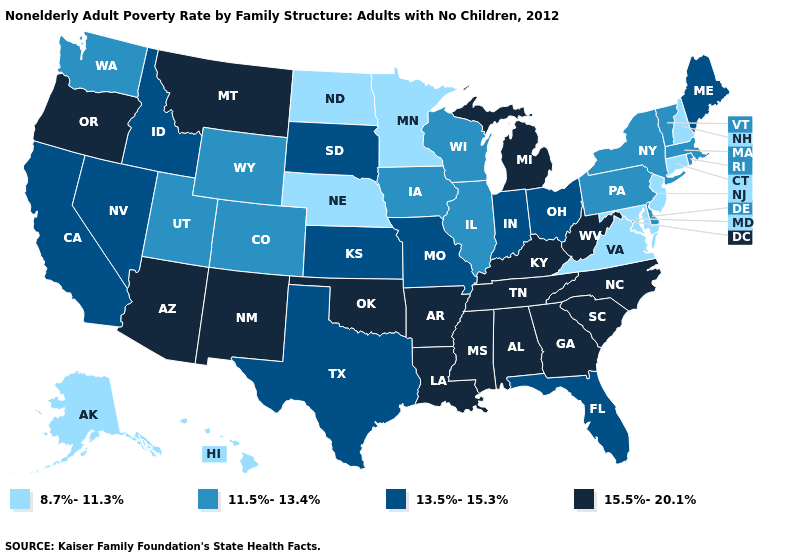Which states have the lowest value in the USA?
Write a very short answer. Alaska, Connecticut, Hawaii, Maryland, Minnesota, Nebraska, New Hampshire, New Jersey, North Dakota, Virginia. Which states have the lowest value in the MidWest?
Write a very short answer. Minnesota, Nebraska, North Dakota. Which states have the lowest value in the West?
Be succinct. Alaska, Hawaii. Name the states that have a value in the range 11.5%-13.4%?
Quick response, please. Colorado, Delaware, Illinois, Iowa, Massachusetts, New York, Pennsylvania, Rhode Island, Utah, Vermont, Washington, Wisconsin, Wyoming. Name the states that have a value in the range 13.5%-15.3%?
Give a very brief answer. California, Florida, Idaho, Indiana, Kansas, Maine, Missouri, Nevada, Ohio, South Dakota, Texas. Which states hav the highest value in the West?
Be succinct. Arizona, Montana, New Mexico, Oregon. Does the first symbol in the legend represent the smallest category?
Write a very short answer. Yes. What is the highest value in the South ?
Answer briefly. 15.5%-20.1%. What is the value of Texas?
Be succinct. 13.5%-15.3%. What is the highest value in the West ?
Concise answer only. 15.5%-20.1%. Does Tennessee have the lowest value in the USA?
Concise answer only. No. Name the states that have a value in the range 8.7%-11.3%?
Keep it brief. Alaska, Connecticut, Hawaii, Maryland, Minnesota, Nebraska, New Hampshire, New Jersey, North Dakota, Virginia. Does Massachusetts have the highest value in the Northeast?
Short answer required. No. Is the legend a continuous bar?
Give a very brief answer. No. What is the value of Minnesota?
Short answer required. 8.7%-11.3%. 